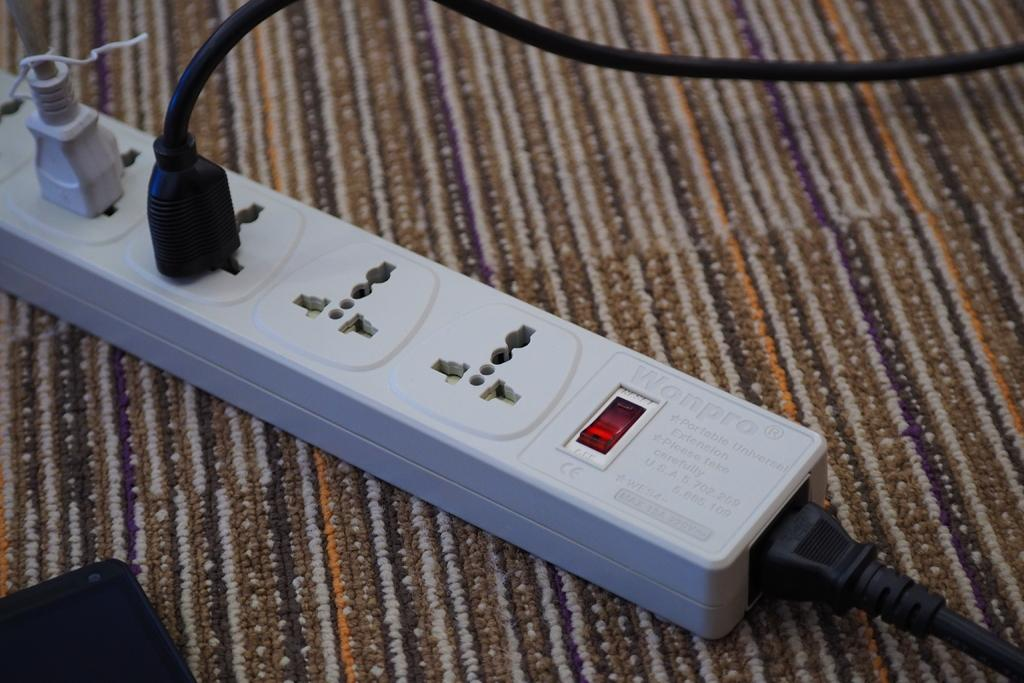What is the color of the socket in the image? The socket in the image is white. How many cables are connected to the socket? Two cables are connected to the socket. What is the surface beneath the socket? The socket is placed on a carpet. Can you describe the object in the bottom left corner of the image? There is a black object in the bottom left corner of the image. What year is depicted in the image? The image does not depict a specific year; it is a photograph of a socket and cables. What action is being performed by the socket in the image? The socket is not performing an action; it is an inanimate object that serves as a power source for the connected cables. 